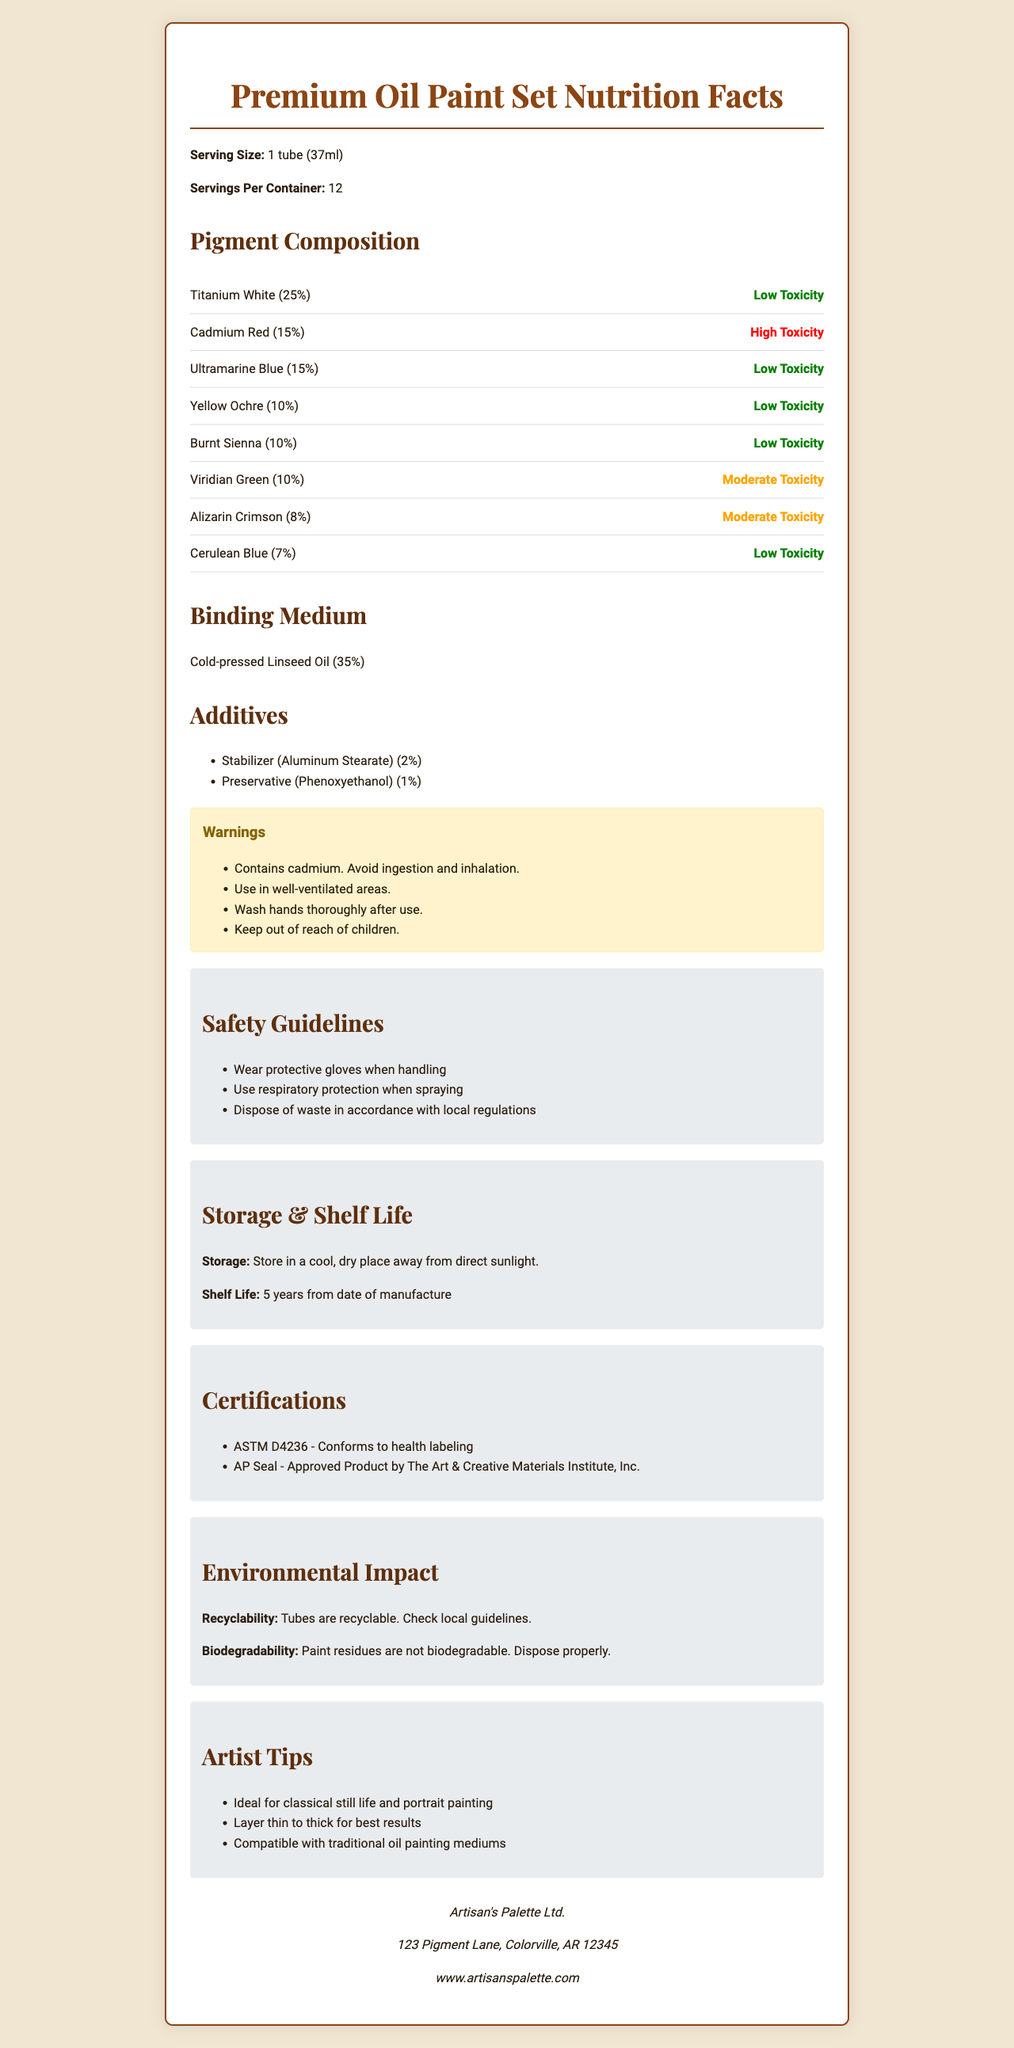what is the serving size for the Premium Oil Paint Set? The document states that the serving size is 1 tube which contains 37ml of paint.
Answer: 1 tube (37ml) which pigment contributes the highest percentage in the composition? According to the pigment composition list, Titanium White contributes 25%, the highest among the listed pigments.
Answer: Titanium White what is the toxicity level of Cadmium Red? The document specifically mentions that Cadmium Red has a high toxicity level.
Answer: High how should the Premium Oil Paint Set be stored? The document lists the storage instructions as storing in a cool, dry place away from direct sunlight.
Answer: In a cool, dry place away from direct sunlight what is the shelf life of the paint set? The document states that the shelf life is 5 years from the date of manufacture.
Answer: 5 years from date of manufacture How many pigments have a low toxicity level? The pigments Titanium White, Ultramarine Blue, Yellow Ochre, Burnt Sienna, and Cerulean Blue are indicated as having low toxicity levels.
Answer: 5 which painting technique is suggested for best results with this oil paint set? The document provides an artist tip that suggests layering thin to thick for the best results.
Answer: Layer thin to thick for best results which pigment has a percentage composition of 10%? A. Titanium White B. Yellow Ochre C. Alizarin Crimson D. Cerulean Blue Yellow Ochre and Burnt Sienna both have 10%, but Yellow Ochre is listed first among the options.
Answer: B what type of medium is used in this oil paint set? Cold-pressed Linseed Oil is listed as the binding medium with a 35% composition.
Answer: Cold-pressed Linseed Oil Does the Premium Oil Paint Set conform to health labeling standards? The document mentions that it conforms to ASTM D4236 - health labeling standards.
Answer: Yes Are the paint residues biodegradable? The document specifies that paint residues are not biodegradable and should be disposed of properly.
Answer: No How many certifications does the Premium Oil Paint Set have? The document lists two certifications: ASTM D4236 and AP Seal.
Answer: 2 Summarize the main idea of the document. The document comprehensively outlines various aspects of the oil paint set from its ingredients to usage guidelines and safety measures, ensuring that users are well-informed about the product.
Answer: The document provides detailed information about the Premium Oil Paint Set, including pigment composition, toxicity levels, binding medium, additives, warnings, safety guidelines, storage instructions, shelf life, manufacturer details, certifications, environmental impact, and artist tips. what is the warning associated with Cadmium Red? The document states that Cadmium Red contains cadmium and users should avoid ingestion and inhalation.
Answer: Avoid ingestion and inhalation. What are the safety guidelines for using this paint set? I. Wear protective gloves II. Use respiratory protection when spraying III. Use in a well-ventilated area IV. Dispose of waste according to local regulations The document lists these safety guidelines explicitly, while "Use in well-ventilated areas" is mentioned under warnings, not safety guidelines.
Answer: I, II, IV What is the address of the manufacturer, Artisan's Palette Ltd.? The manufacturer information is explicitly provided in the document.
Answer: 123 Pigment Lane, Colorville, AR 12345 when can protective gloves be omitted while handling the paints? The document does not state specific situations when protective gloves can be omitted.
Answer: Not enough information 